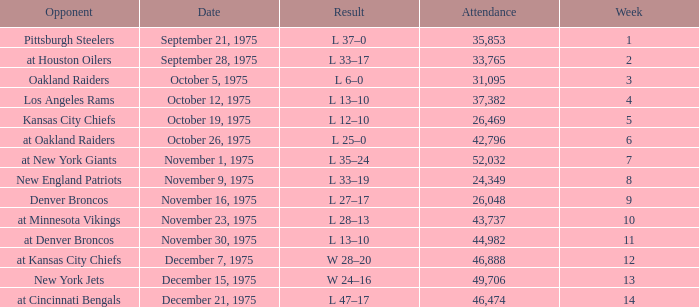What is the average Week when the result was w 28–20, and there were more than 46,888 in attendance? None. 